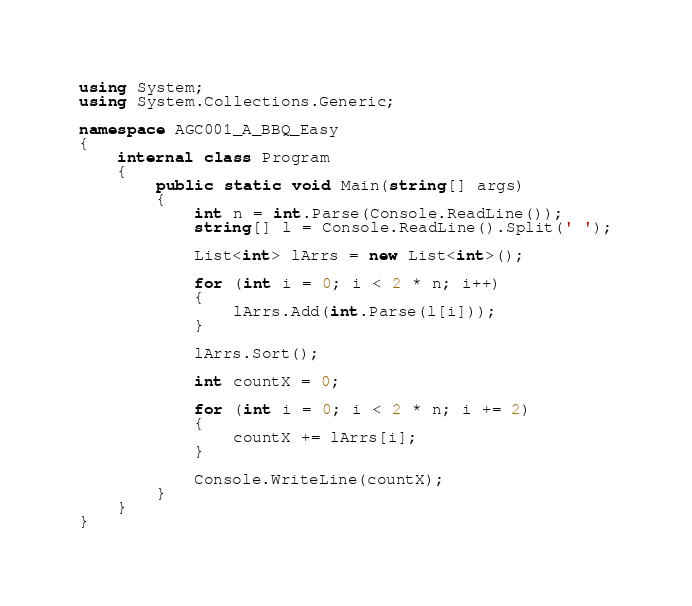Convert code to text. <code><loc_0><loc_0><loc_500><loc_500><_C#_>using System;
using System.Collections.Generic;

namespace AGC001_A_BBQ_Easy
{
	internal class Program
	{
		public static void Main(string[] args)
		{
			int n = int.Parse(Console.ReadLine());
			string[] l = Console.ReadLine().Split(' ');
			
			List<int> lArrs = new List<int>();

			for (int i = 0; i < 2 * n; i++)
			{
				lArrs.Add(int.Parse(l[i]));
			}
			
			lArrs.Sort();

			int countX = 0;

			for (int i = 0; i < 2 * n; i += 2)
			{
				countX += lArrs[i];
			}
			
			Console.WriteLine(countX);
		}
	}
}</code> 